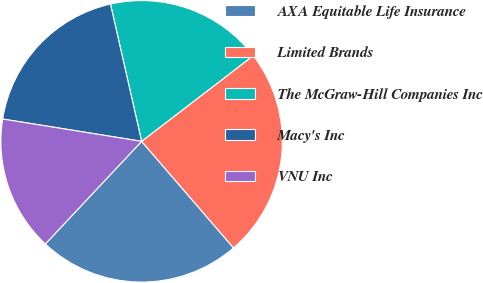<chart> <loc_0><loc_0><loc_500><loc_500><pie_chart><fcel>AXA Equitable Life Insurance<fcel>Limited Brands<fcel>The McGraw-Hill Companies Inc<fcel>Macy's Inc<fcel>VNU Inc<nl><fcel>23.32%<fcel>24.09%<fcel>18.13%<fcel>18.91%<fcel>15.54%<nl></chart> 